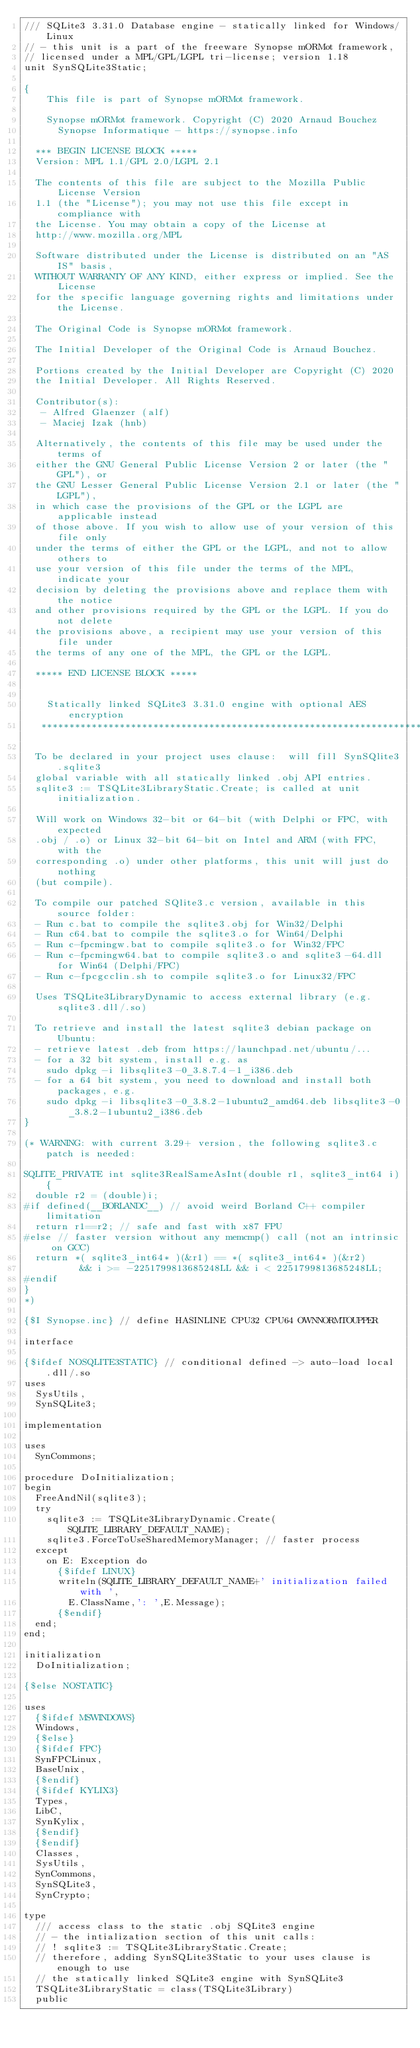Convert code to text. <code><loc_0><loc_0><loc_500><loc_500><_Pascal_>/// SQLite3 3.31.0 Database engine - statically linked for Windows/Linux
// - this unit is a part of the freeware Synopse mORMot framework,
// licensed under a MPL/GPL/LGPL tri-license; version 1.18
unit SynSQLite3Static;

{
    This file is part of Synopse mORMot framework.

    Synopse mORMot framework. Copyright (C) 2020 Arnaud Bouchez
      Synopse Informatique - https://synopse.info

  *** BEGIN LICENSE BLOCK *****
  Version: MPL 1.1/GPL 2.0/LGPL 2.1

  The contents of this file are subject to the Mozilla Public License Version
  1.1 (the "License"); you may not use this file except in compliance with
  the License. You may obtain a copy of the License at
  http://www.mozilla.org/MPL

  Software distributed under the License is distributed on an "AS IS" basis,
  WITHOUT WARRANTY OF ANY KIND, either express or implied. See the License
  for the specific language governing rights and limitations under the License.

  The Original Code is Synopse mORMot framework.

  The Initial Developer of the Original Code is Arnaud Bouchez.

  Portions created by the Initial Developer are Copyright (C) 2020
  the Initial Developer. All Rights Reserved.

  Contributor(s):
   - Alfred Glaenzer (alf)
   - Maciej Izak (hnb)

  Alternatively, the contents of this file may be used under the terms of
  either the GNU General Public License Version 2 or later (the "GPL"), or
  the GNU Lesser General Public License Version 2.1 or later (the "LGPL"),
  in which case the provisions of the GPL or the LGPL are applicable instead
  of those above. If you wish to allow use of your version of this file only
  under the terms of either the GPL or the LGPL, and not to allow others to
  use your version of this file under the terms of the MPL, indicate your
  decision by deleting the provisions above and replace them with the notice
  and other provisions required by the GPL or the LGPL. If you do not delete
  the provisions above, a recipient may use your version of this file under
  the terms of any one of the MPL, the GPL or the LGPL.

  ***** END LICENSE BLOCK *****


    Statically linked SQLite3 3.31.0 engine with optional AES encryption
   **********************************************************************

  To be declared in your project uses clause:  will fill SynSQlite3.sqlite3
  global variable with all statically linked .obj API entries.
  sqlite3 := TSQLite3LibraryStatic.Create; is called at unit initialization.

  Will work on Windows 32-bit or 64-bit (with Delphi or FPC, with expected
  .obj / .o) or Linux 32-bit 64-bit on Intel and ARM (with FPC, with the
  corresponding .o) under other platforms, this unit will just do nothing
  (but compile).

  To compile our patched SQlite3.c version, available in this source folder:
  - Run c.bat to compile the sqlite3.obj for Win32/Delphi
  - Run c64.bat to compile the sqlite3.o for Win64/Delphi
  - Run c-fpcmingw.bat to compile sqlite3.o for Win32/FPC
  - Run c-fpcmingw64.bat to compile sqlite3.o and sqlite3-64.dll for Win64 (Delphi/FPC)
  - Run c-fpcgcclin.sh to compile sqlite3.o for Linux32/FPC

  Uses TSQLite3LibraryDynamic to access external library (e.g. sqlite3.dll/.so)

  To retrieve and install the latest sqlite3 debian package on Ubuntu:
  - retrieve latest .deb from https://launchpad.net/ubuntu/...
  - for a 32 bit system, install e.g. as
    sudo dpkg -i libsqlite3-0_3.8.7.4-1_i386.deb
  - for a 64 bit system, you need to download and install both packages, e.g.
    sudo dpkg -i libsqlite3-0_3.8.2-1ubuntu2_amd64.deb libsqlite3-0_3.8.2-1ubuntu2_i386.deb
}

(* WARNING: with current 3.29+ version, the following sqlite3.c patch is needed:

SQLITE_PRIVATE int sqlite3RealSameAsInt(double r1, sqlite3_int64 i){
  double r2 = (double)i;
#if defined(__BORLANDC__) // avoid weird Borland C++ compiler limitation
  return r1==r2; // safe and fast with x87 FPU
#else // faster version without any memcmp() call (not an intrinsic on GCC)
  return *( sqlite3_int64* )(&r1) == *( sqlite3_int64* )(&r2)
          && i >= -2251799813685248LL && i < 2251799813685248LL;
#endif
}
*)

{$I Synopse.inc} // define HASINLINE CPU32 CPU64 OWNNORMTOUPPER

interface

{$ifdef NOSQLITE3STATIC} // conditional defined -> auto-load local .dll/.so
uses
  SysUtils,
  SynSQLite3;

implementation

uses
  SynCommons;

procedure DoInitialization;
begin
  FreeAndNil(sqlite3);
  try
    sqlite3 := TSQLite3LibraryDynamic.Create(SQLITE_LIBRARY_DEFAULT_NAME);
    sqlite3.ForceToUseSharedMemoryManager; // faster process
  except
    on E: Exception do
      {$ifdef LINUX}
      writeln(SQLITE_LIBRARY_DEFAULT_NAME+' initialization failed with ',
        E.ClassName,': ',E.Message);
      {$endif}
  end;
end;

initialization
  DoInitialization;

{$else NOSTATIC}

uses
  {$ifdef MSWINDOWS}
  Windows,
  {$else}
  {$ifdef FPC}
  SynFPCLinux,
  BaseUnix,
  {$endif}
  {$ifdef KYLIX3}
  Types,
  LibC,
  SynKylix,
  {$endif}
  {$endif}
  Classes,
  SysUtils,
  SynCommons,
  SynSQLite3,
  SynCrypto;

type
  /// access class to the static .obj SQLite3 engine
  // - the intialization section of this unit calls:
  // ! sqlite3 := TSQLite3LibraryStatic.Create;
  // therefore, adding SynSQLite3Static to your uses clause is enough to use
  // the statically linked SQLite3 engine with SynSQLite3
  TSQLite3LibraryStatic = class(TSQLite3Library)
  public</code> 